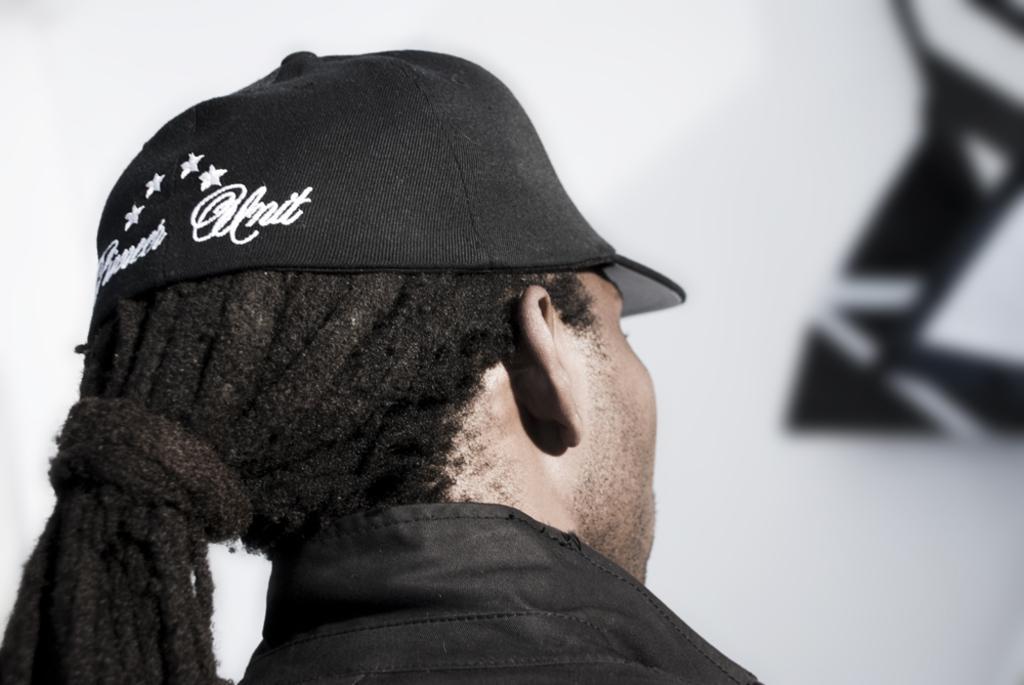In one or two sentences, can you explain what this image depicts? In the image we can see a person wearing clothes and cap. The background is white with black design 